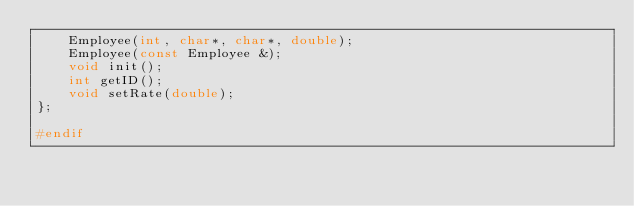<code> <loc_0><loc_0><loc_500><loc_500><_C_>		Employee(int, char*, char*, double);
		Employee(const Employee &);
		void init();
		int getID();
		void setRate(double);
};

#endif

</code> 